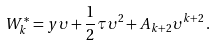Convert formula to latex. <formula><loc_0><loc_0><loc_500><loc_500>W _ { k } ^ { * } = { y } { \upsilon } + \frac { 1 } { 2 } { \tau } { \upsilon } ^ { 2 } + A _ { k + 2 } { \upsilon } ^ { k + 2 } \, .</formula> 